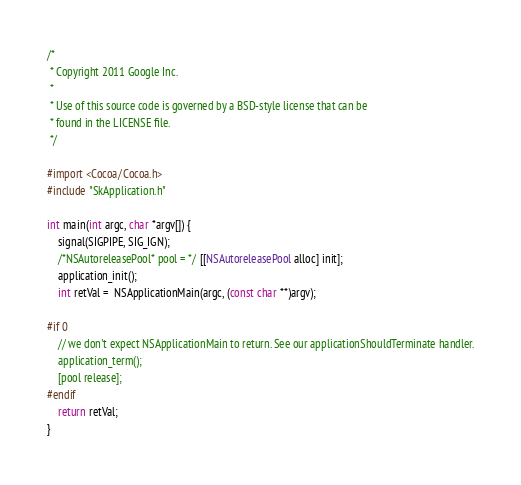<code> <loc_0><loc_0><loc_500><loc_500><_ObjectiveC_>
/*
 * Copyright 2011 Google Inc.
 *
 * Use of this source code is governed by a BSD-style license that can be
 * found in the LICENSE file.
 */

#import <Cocoa/Cocoa.h>
#include "SkApplication.h"

int main(int argc, char *argv[]) {
    signal(SIGPIPE, SIG_IGN);
    /*NSAutoreleasePool* pool = */ [[NSAutoreleasePool alloc] init];
    application_init();
    int retVal =  NSApplicationMain(argc, (const char **)argv);
    
#if 0
    // we don't expect NSApplicationMain to return. See our applicationShouldTerminate handler.
    application_term();
    [pool release];
#endif
    return retVal;
}
</code> 